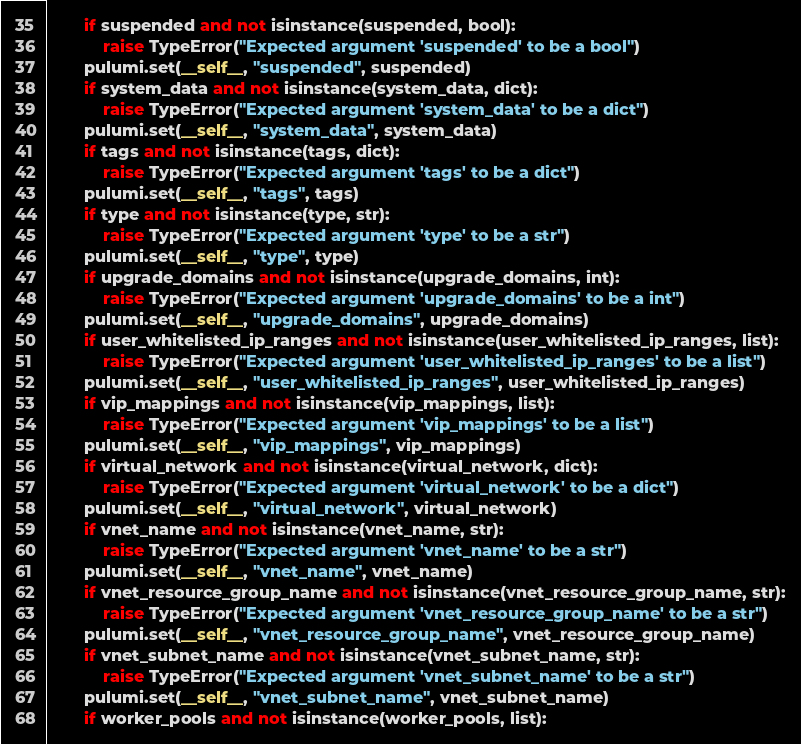<code> <loc_0><loc_0><loc_500><loc_500><_Python_>        if suspended and not isinstance(suspended, bool):
            raise TypeError("Expected argument 'suspended' to be a bool")
        pulumi.set(__self__, "suspended", suspended)
        if system_data and not isinstance(system_data, dict):
            raise TypeError("Expected argument 'system_data' to be a dict")
        pulumi.set(__self__, "system_data", system_data)
        if tags and not isinstance(tags, dict):
            raise TypeError("Expected argument 'tags' to be a dict")
        pulumi.set(__self__, "tags", tags)
        if type and not isinstance(type, str):
            raise TypeError("Expected argument 'type' to be a str")
        pulumi.set(__self__, "type", type)
        if upgrade_domains and not isinstance(upgrade_domains, int):
            raise TypeError("Expected argument 'upgrade_domains' to be a int")
        pulumi.set(__self__, "upgrade_domains", upgrade_domains)
        if user_whitelisted_ip_ranges and not isinstance(user_whitelisted_ip_ranges, list):
            raise TypeError("Expected argument 'user_whitelisted_ip_ranges' to be a list")
        pulumi.set(__self__, "user_whitelisted_ip_ranges", user_whitelisted_ip_ranges)
        if vip_mappings and not isinstance(vip_mappings, list):
            raise TypeError("Expected argument 'vip_mappings' to be a list")
        pulumi.set(__self__, "vip_mappings", vip_mappings)
        if virtual_network and not isinstance(virtual_network, dict):
            raise TypeError("Expected argument 'virtual_network' to be a dict")
        pulumi.set(__self__, "virtual_network", virtual_network)
        if vnet_name and not isinstance(vnet_name, str):
            raise TypeError("Expected argument 'vnet_name' to be a str")
        pulumi.set(__self__, "vnet_name", vnet_name)
        if vnet_resource_group_name and not isinstance(vnet_resource_group_name, str):
            raise TypeError("Expected argument 'vnet_resource_group_name' to be a str")
        pulumi.set(__self__, "vnet_resource_group_name", vnet_resource_group_name)
        if vnet_subnet_name and not isinstance(vnet_subnet_name, str):
            raise TypeError("Expected argument 'vnet_subnet_name' to be a str")
        pulumi.set(__self__, "vnet_subnet_name", vnet_subnet_name)
        if worker_pools and not isinstance(worker_pools, list):</code> 